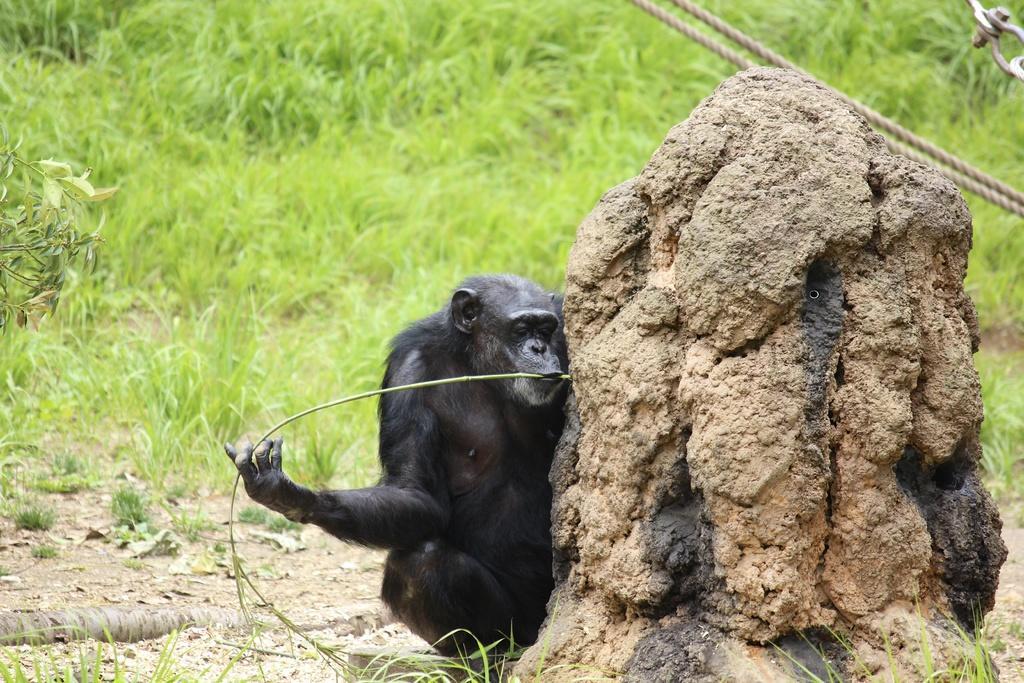Please provide a concise description of this image. There is a chimpanzee holding a stem and a stone in the foreground area of the image, there are ropes and grassland in the background. 